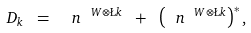Convert formula to latex. <formula><loc_0><loc_0><loc_500><loc_500>D _ { k } \ = \ \ n ^ { \ W \otimes \L k } \ + \ \left ( \ n ^ { \ W \otimes \L k } \right ) ^ { * } ,</formula> 